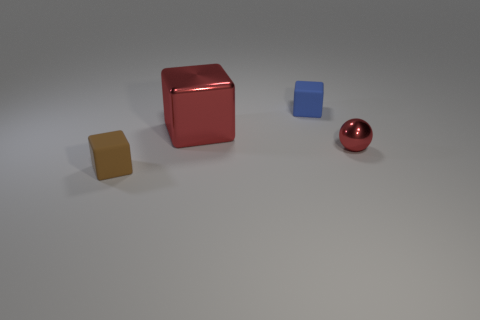Add 1 tiny blue matte blocks. How many objects exist? 5 Subtract all balls. How many objects are left? 3 Add 1 tiny red spheres. How many tiny red spheres exist? 2 Subtract 0 gray cylinders. How many objects are left? 4 Subtract all rubber cubes. Subtract all small blue rubber objects. How many objects are left? 1 Add 1 small brown things. How many small brown things are left? 2 